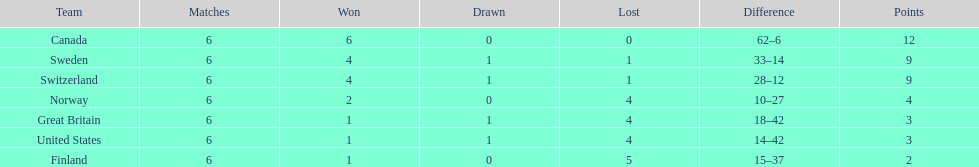Which country conceded the least goals? Finland. 